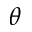<formula> <loc_0><loc_0><loc_500><loc_500>\theta</formula> 